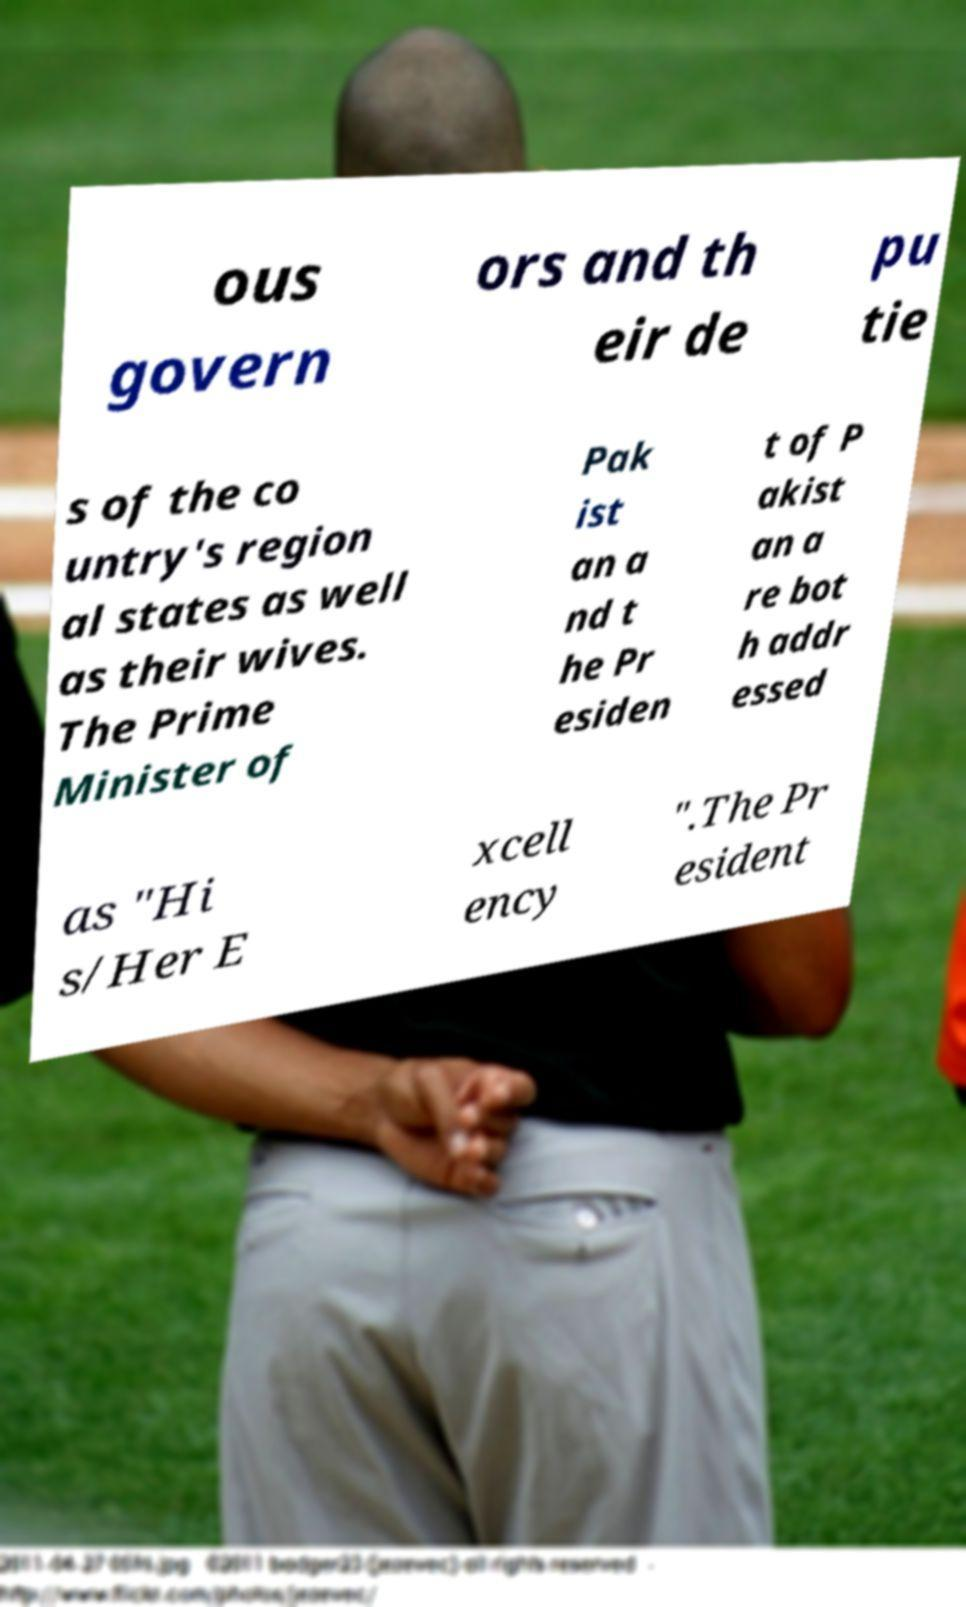Can you accurately transcribe the text from the provided image for me? ous govern ors and th eir de pu tie s of the co untry's region al states as well as their wives. The Prime Minister of Pak ist an a nd t he Pr esiden t of P akist an a re bot h addr essed as "Hi s/Her E xcell ency ".The Pr esident 